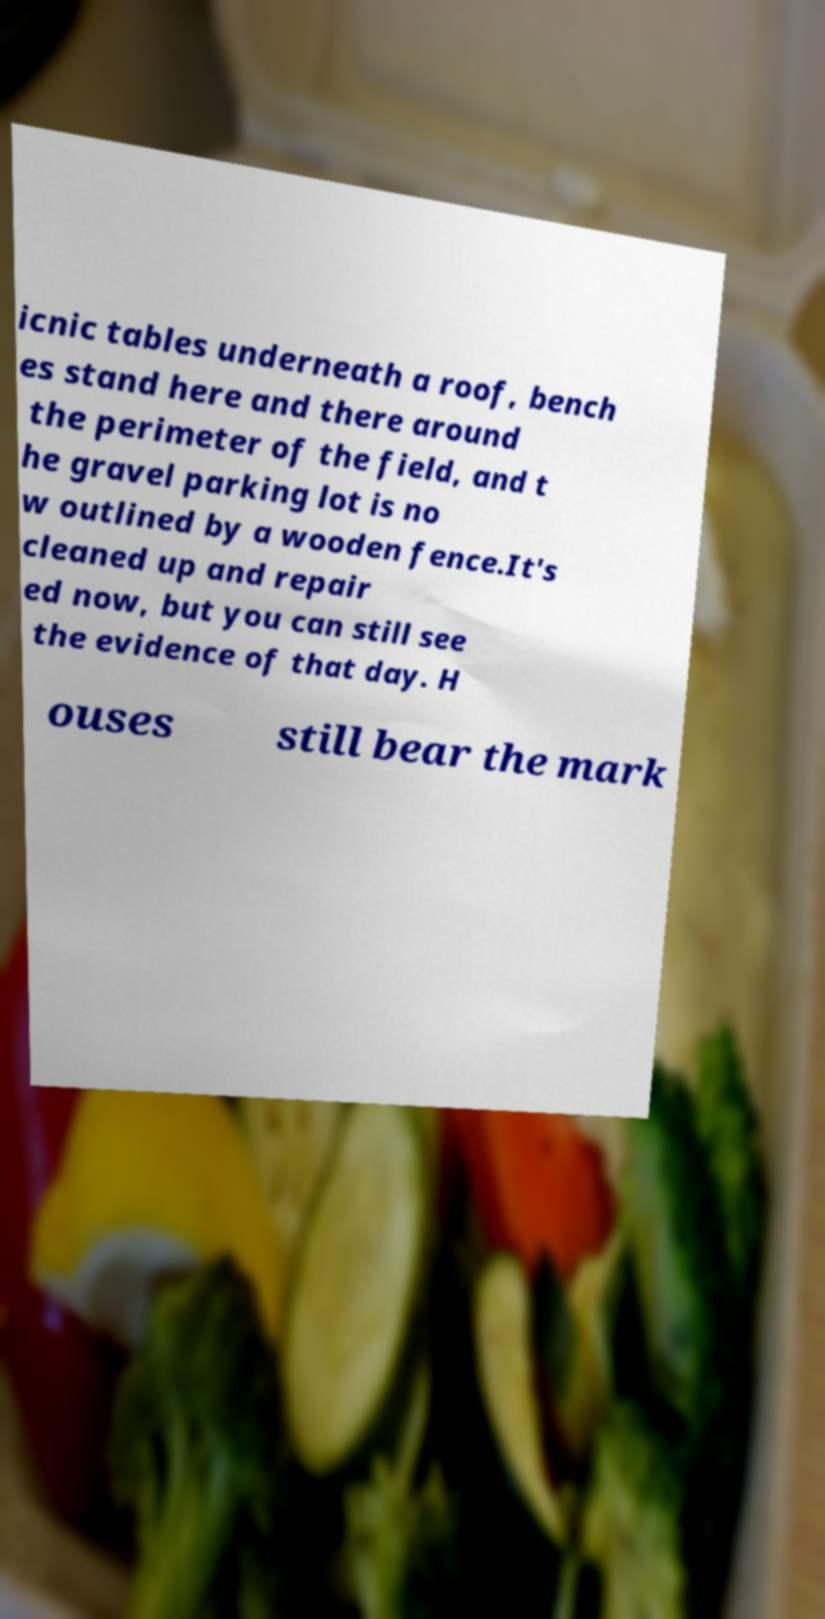I need the written content from this picture converted into text. Can you do that? icnic tables underneath a roof, bench es stand here and there around the perimeter of the field, and t he gravel parking lot is no w outlined by a wooden fence.It's cleaned up and repair ed now, but you can still see the evidence of that day. H ouses still bear the mark 